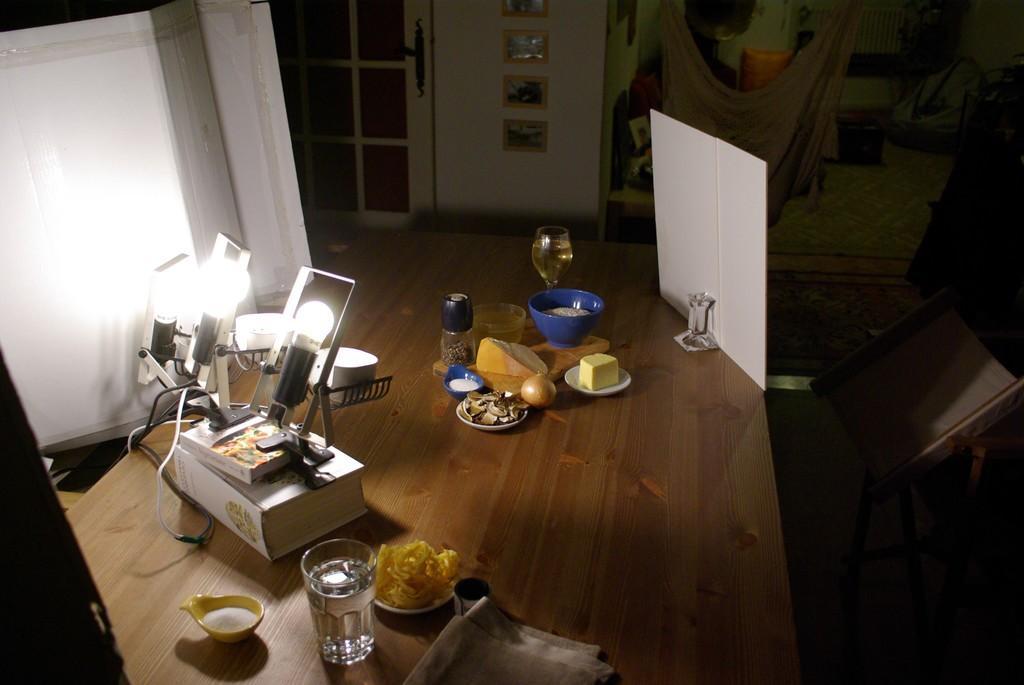How would you summarize this image in a sentence or two? In this picture there is a table in the center of the image, which contains food items, glasses, and lights on it, there is a door and portraits at the top side of the image. 